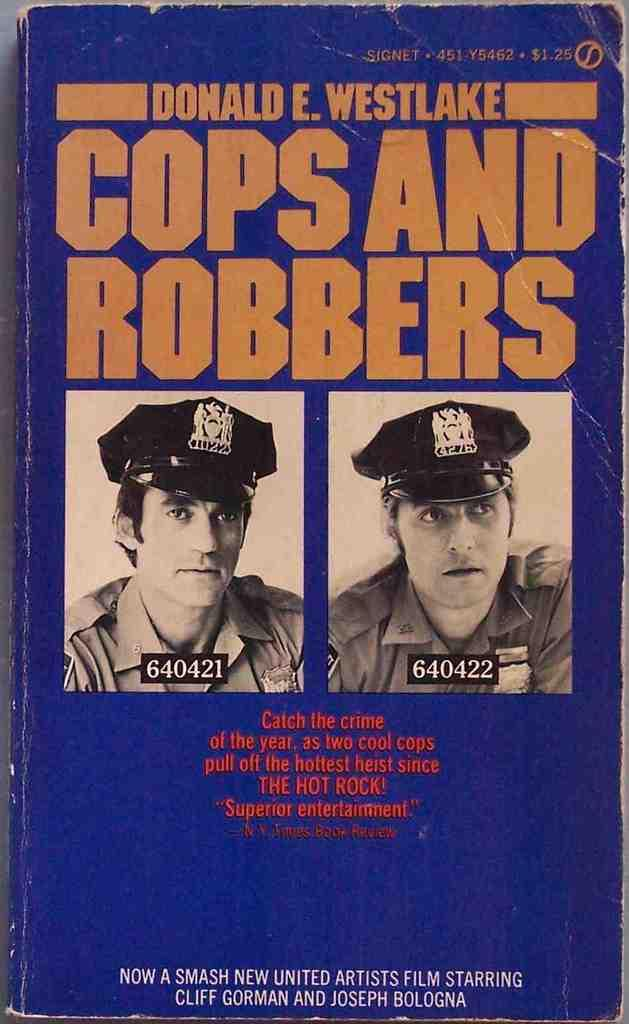What object is present in the image that is typically used for reading? There is a book in the image. What can be found on the book? The book has text on it. Are there any illustrations on the book? Yes, there are two images of persons on the book. What type of guitar can be seen in the image? There is no guitar present in the image. Is there a sink visible in the image? No, there is no sink present in the image. 